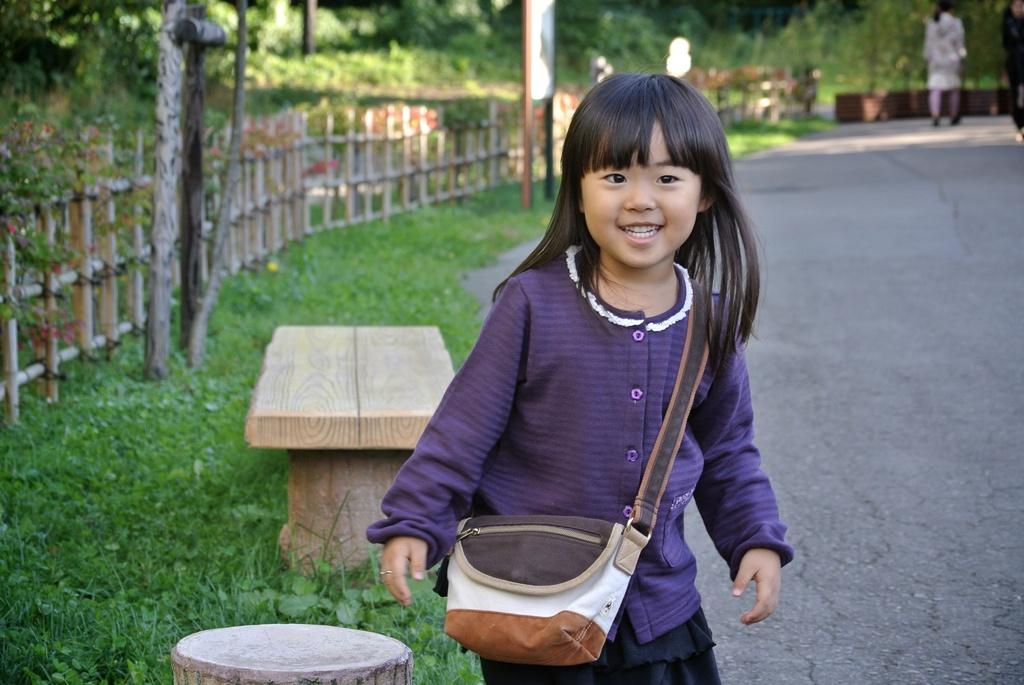Who is present in the image? There is a girl in the image. What is the girl wearing on her back? The girl is wearing a sling bag. What type of seating is visible in the image? There is a wooden bench in the image. What type of barriers can be seen in the image? There are fences in the image. What type of vegetation is present in the image? There is grass and trees in the image. What type of vertical structures are present in the image? There are poles in the image. Are there any other people visible in the image? Yes, there is a person at the back of the image. What type of underwear is the girl wearing in the image? There is no information about the girl's underwear in the image, and it is not visible. What type of quilt is covering the wooden bench in the image? There is no quilt present in the image; the wooden bench is not covered. 